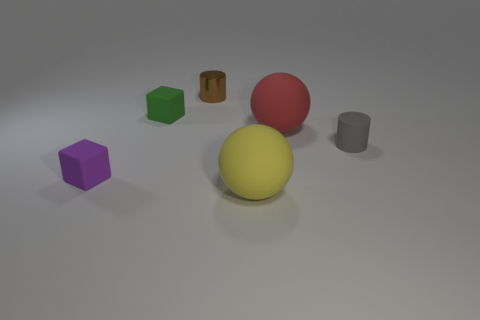Add 1 blue matte cubes. How many objects exist? 7 Add 4 tiny green objects. How many tiny green objects are left? 5 Add 5 big purple matte things. How many big purple matte things exist? 5 Subtract 0 gray cubes. How many objects are left? 6 Subtract all blocks. How many objects are left? 4 Subtract all small green rubber blocks. Subtract all tiny yellow spheres. How many objects are left? 5 